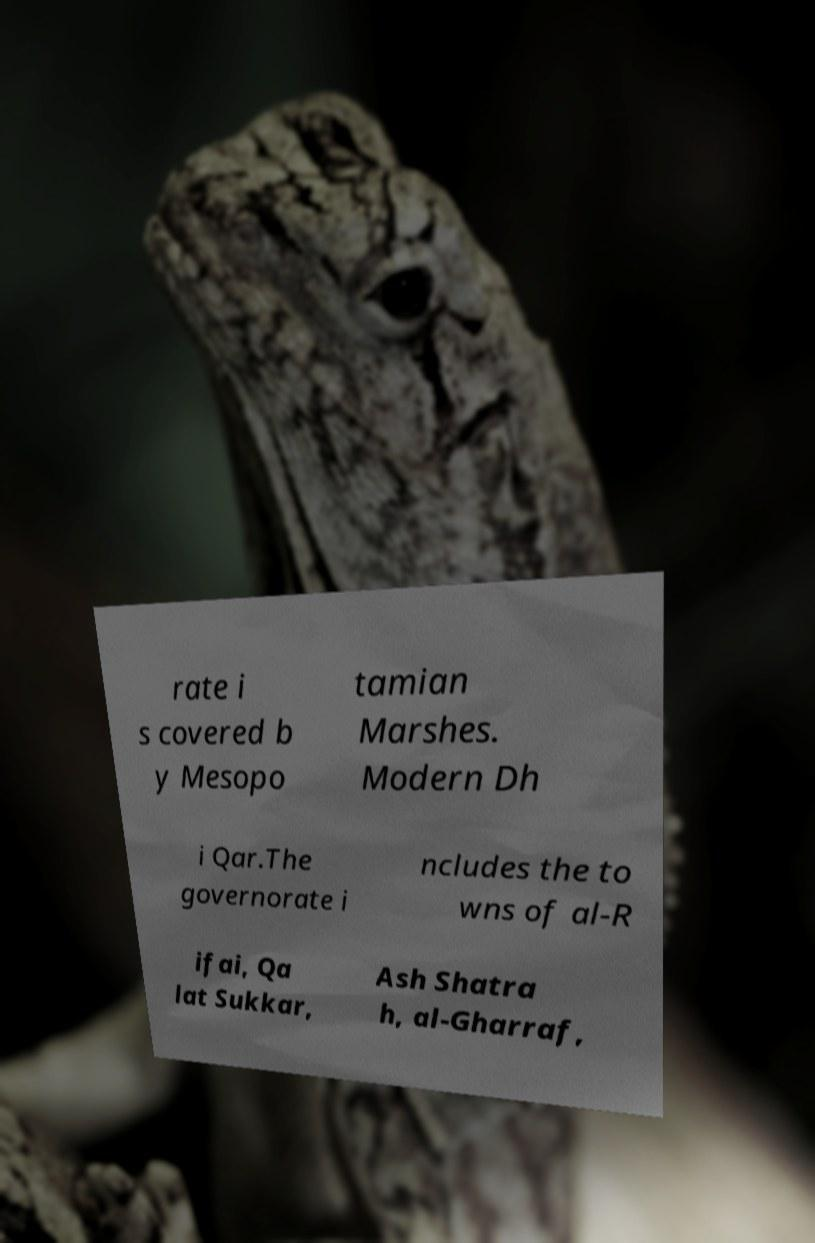I need the written content from this picture converted into text. Can you do that? rate i s covered b y Mesopo tamian Marshes. Modern Dh i Qar.The governorate i ncludes the to wns of al-R ifai, Qa lat Sukkar, Ash Shatra h, al-Gharraf, 